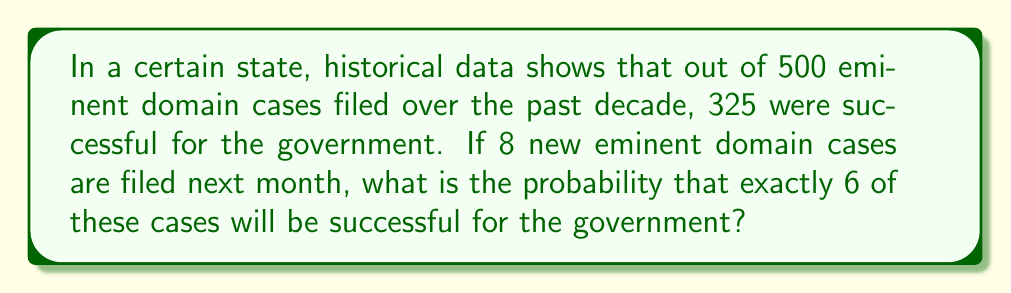What is the answer to this math problem? To solve this problem, we'll use the binomial probability formula, as we're dealing with a fixed number of independent trials (8 cases) with two possible outcomes for each (success or failure).

Step 1: Calculate the probability of success for a single case.
$p = \frac{\text{Successful cases}}{\text{Total cases}} = \frac{325}{500} = 0.65$

Step 2: The probability of failure for a single case is:
$q = 1 - p = 1 - 0.65 = 0.35$

Step 3: We want exactly 6 successes out of 8 trials. We'll use the binomial probability formula:

$$P(X = k) = \binom{n}{k} p^k q^{n-k}$$

Where:
$n = 8$ (total number of cases)
$k = 6$ (number of successes we want)
$p = 0.65$ (probability of success for each case)
$q = 0.35$ (probability of failure for each case)

Step 4: Calculate the binomial coefficient:
$$\binom{8}{6} = \frac{8!}{6!(8-6)!} = \frac{8!}{6!2!} = 28$$

Step 5: Plug all values into the formula:

$$P(X = 6) = 28 \cdot (0.65)^6 \cdot (0.35)^{8-6}$$
$$= 28 \cdot (0.65)^6 \cdot (0.35)^2$$
$$= 28 \cdot 0.075400596 \cdot 0.1225$$
$$= 0.2580$$

Therefore, the probability of exactly 6 out of 8 new eminent domain cases being successful for the government is approximately 0.2580 or 25.80%.
Answer: $0.2580$ or $25.80\%$ 